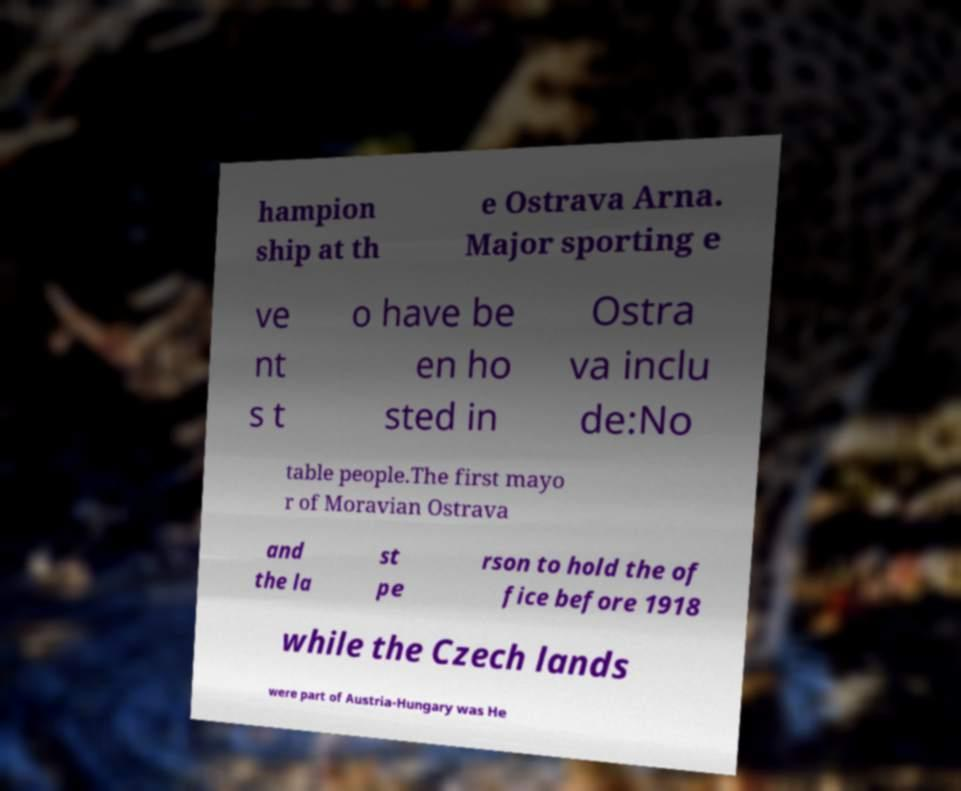Can you read and provide the text displayed in the image?This photo seems to have some interesting text. Can you extract and type it out for me? hampion ship at th e Ostrava Arna. Major sporting e ve nt s t o have be en ho sted in Ostra va inclu de:No table people.The first mayo r of Moravian Ostrava and the la st pe rson to hold the of fice before 1918 while the Czech lands were part of Austria-Hungary was He 